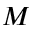Convert formula to latex. <formula><loc_0><loc_0><loc_500><loc_500>M</formula> 